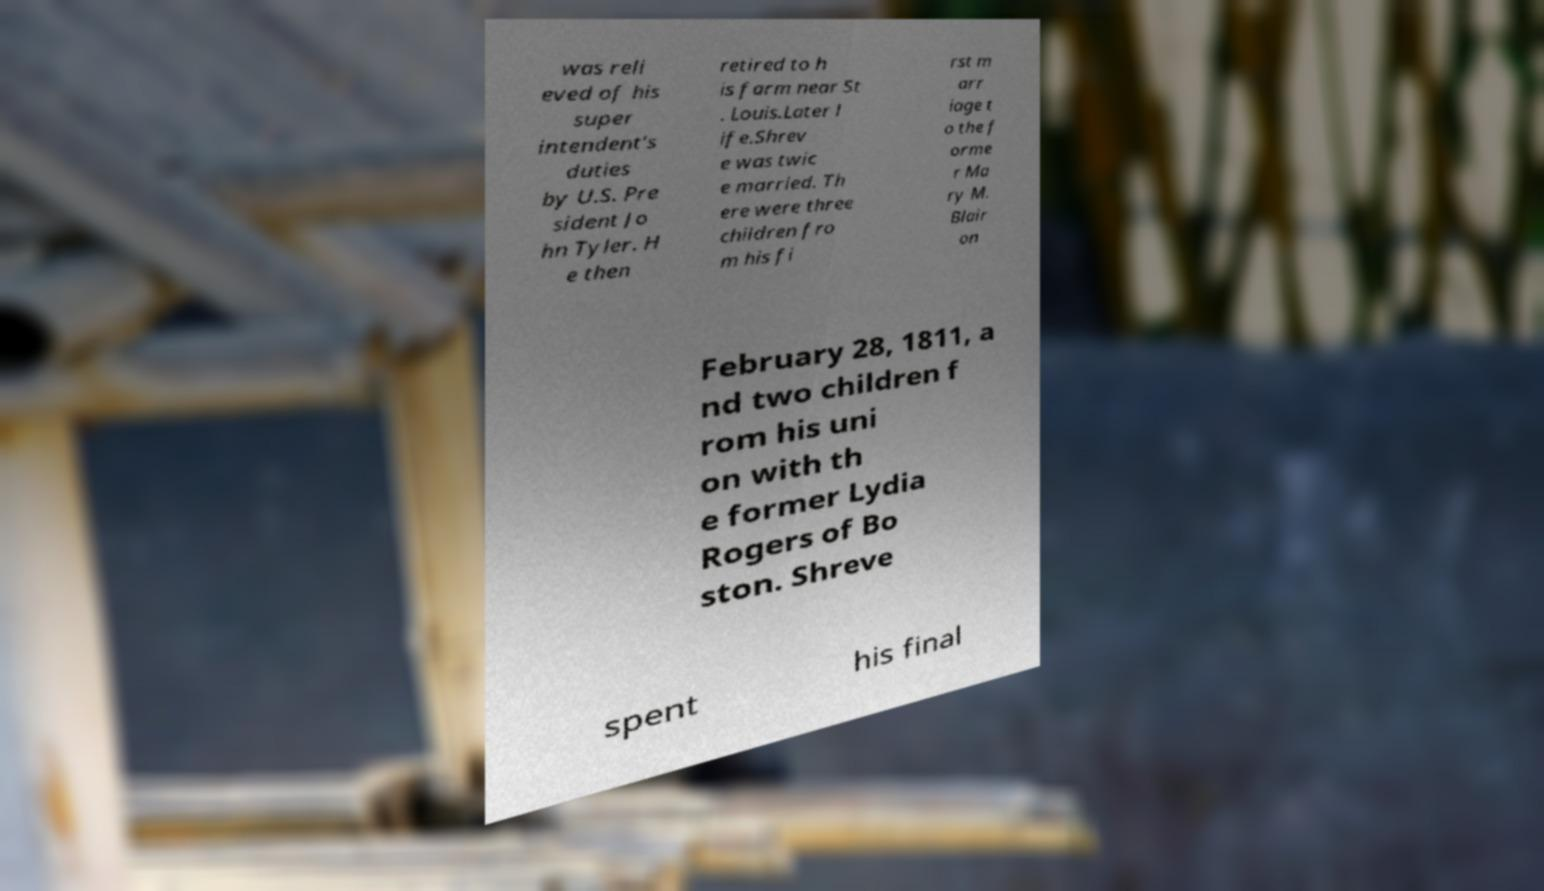Could you extract and type out the text from this image? was reli eved of his super intendent's duties by U.S. Pre sident Jo hn Tyler. H e then retired to h is farm near St . Louis.Later l ife.Shrev e was twic e married. Th ere were three children fro m his fi rst m arr iage t o the f orme r Ma ry M. Blair on February 28, 1811, a nd two children f rom his uni on with th e former Lydia Rogers of Bo ston. Shreve spent his final 